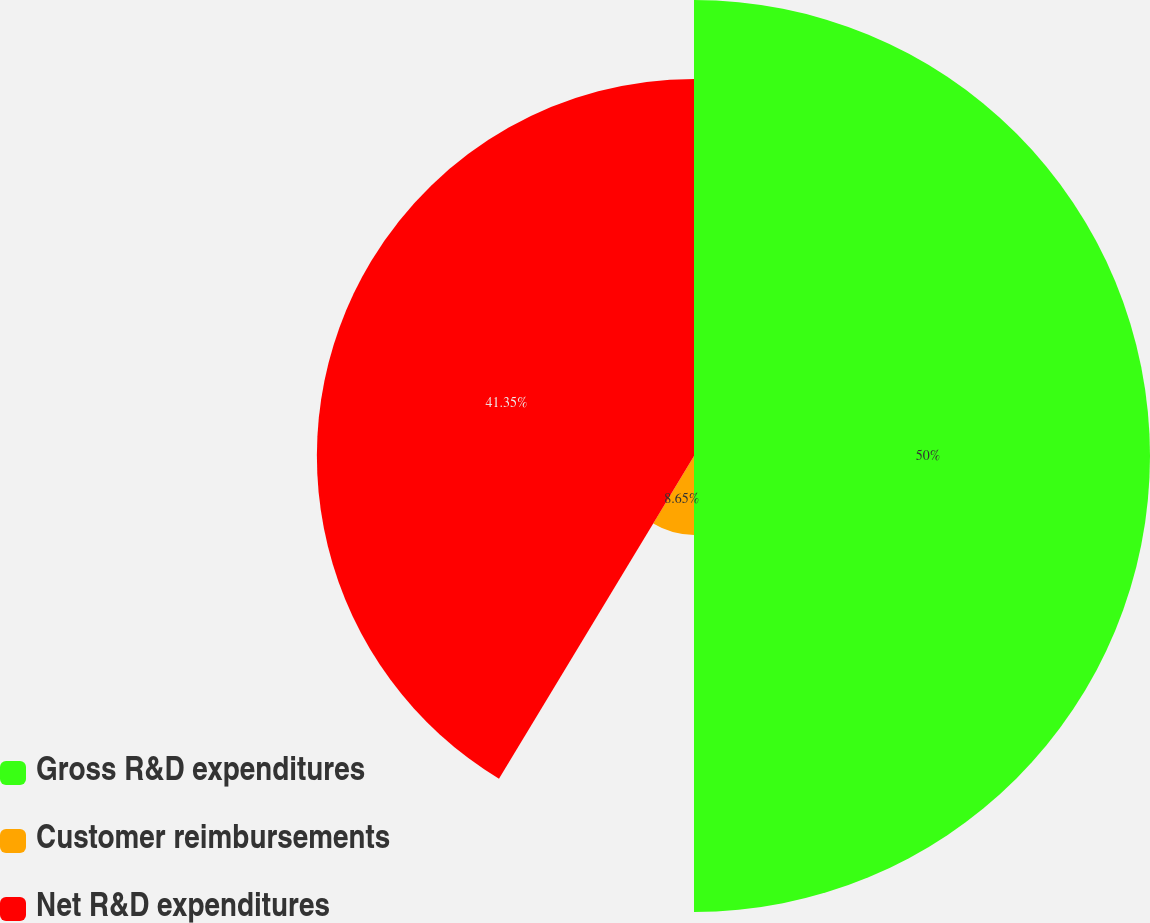Convert chart. <chart><loc_0><loc_0><loc_500><loc_500><pie_chart><fcel>Gross R&D expenditures<fcel>Customer reimbursements<fcel>Net R&D expenditures<nl><fcel>50.0%<fcel>8.65%<fcel>41.35%<nl></chart> 